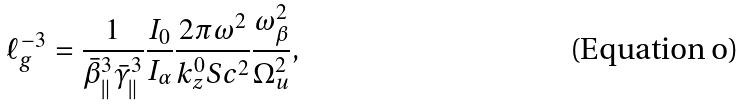Convert formula to latex. <formula><loc_0><loc_0><loc_500><loc_500>\ell _ { g } ^ { - 3 } = \frac { 1 } { \bar { \beta } _ { \| } ^ { 3 } \bar { \gamma } _ { \| } ^ { 3 } } \frac { I _ { 0 } } { I _ { \alpha } } \frac { 2 \pi \omega ^ { 2 } } { k _ { z } ^ { 0 } S c ^ { 2 } } \frac { \omega _ { \beta } ^ { 2 } } { \Omega _ { u } ^ { 2 } } ,</formula> 